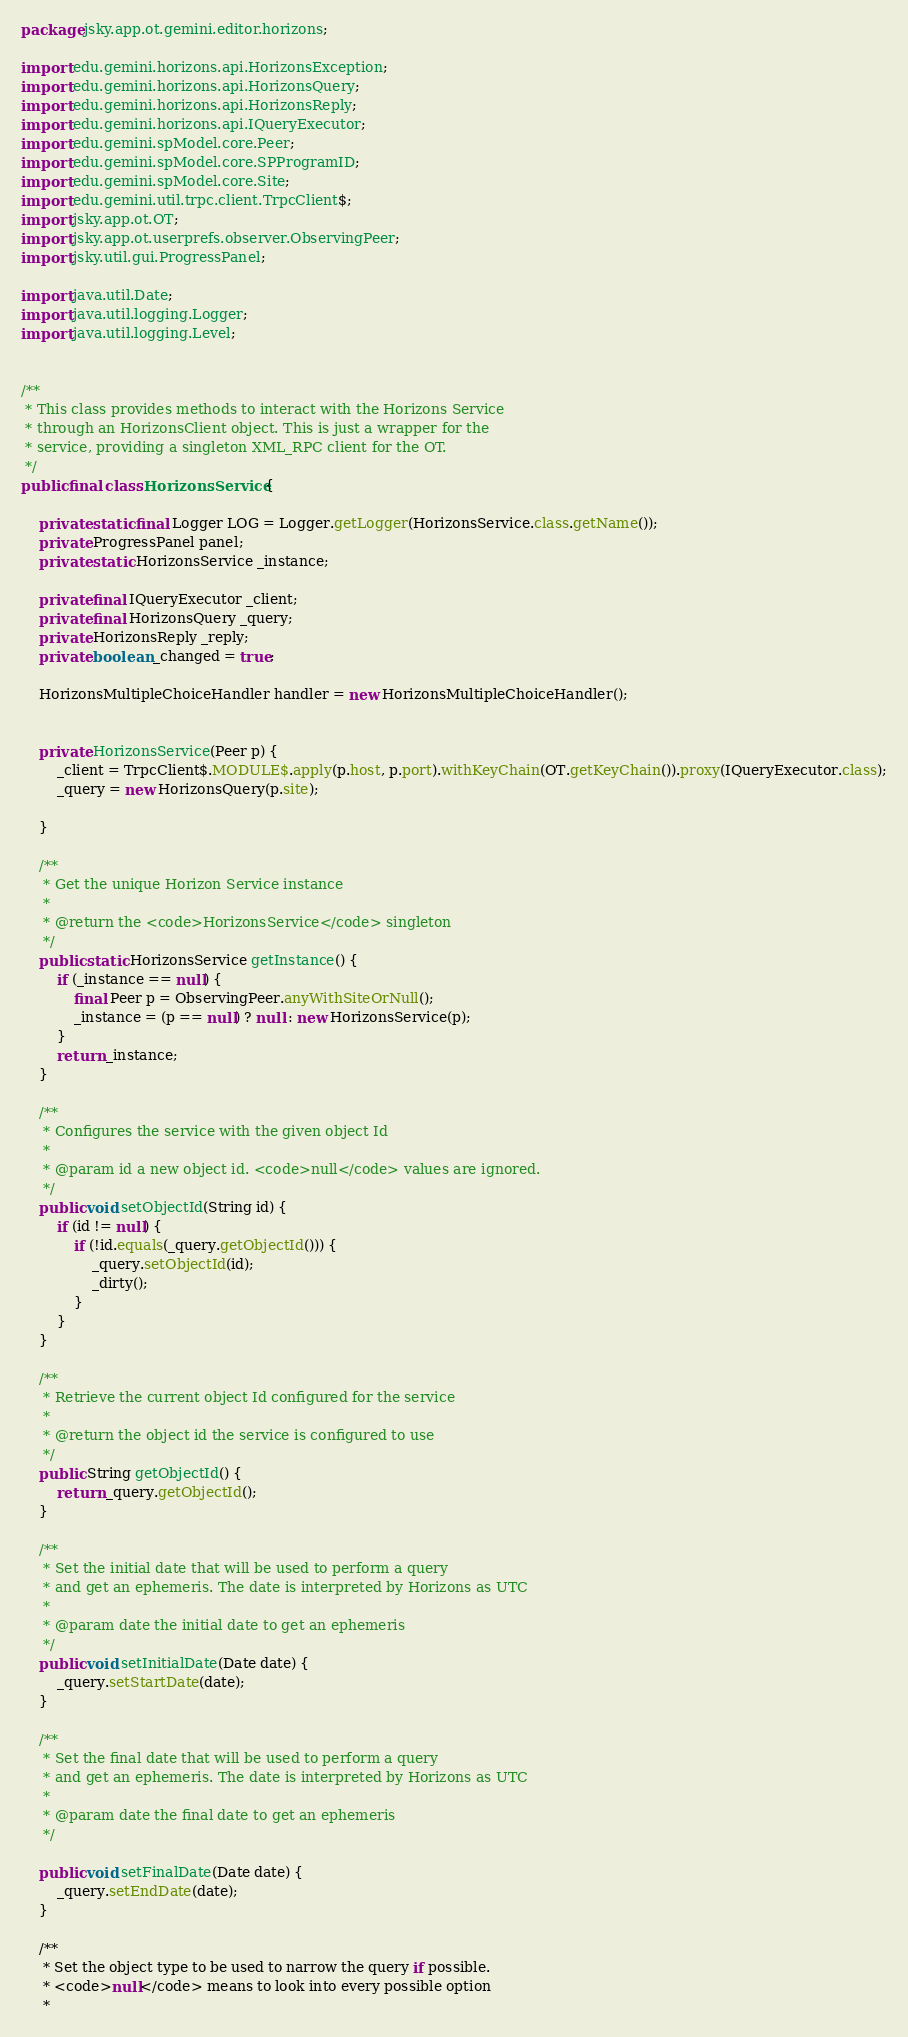<code> <loc_0><loc_0><loc_500><loc_500><_Java_>package jsky.app.ot.gemini.editor.horizons;

import edu.gemini.horizons.api.HorizonsException;
import edu.gemini.horizons.api.HorizonsQuery;
import edu.gemini.horizons.api.HorizonsReply;
import edu.gemini.horizons.api.IQueryExecutor;
import edu.gemini.spModel.core.Peer;
import edu.gemini.spModel.core.SPProgramID;
import edu.gemini.spModel.core.Site;
import edu.gemini.util.trpc.client.TrpcClient$;
import jsky.app.ot.OT;
import jsky.app.ot.userprefs.observer.ObservingPeer;
import jsky.util.gui.ProgressPanel;

import java.util.Date;
import java.util.logging.Logger;
import java.util.logging.Level;


/**
 * This class provides methods to interact with the Horizons Service
 * through an HorizonsClient object. This is just a wrapper for the
 * service, providing a singleton XML_RPC client for the OT.
 */
public final class HorizonsService {

    private static final Logger LOG = Logger.getLogger(HorizonsService.class.getName());
    private ProgressPanel panel;
    private static HorizonsService _instance;

    private final IQueryExecutor _client;
    private final HorizonsQuery _query;
    private HorizonsReply _reply;
    private boolean _changed = true;

    HorizonsMultipleChoiceHandler handler = new HorizonsMultipleChoiceHandler();


    private HorizonsService(Peer p) {
        _client = TrpcClient$.MODULE$.apply(p.host, p.port).withKeyChain(OT.getKeyChain()).proxy(IQueryExecutor.class);
        _query = new HorizonsQuery(p.site);

    }

    /**
     * Get the unique Horizon Service instance
     *
     * @return the <code>HorizonsService</code> singleton
     */
    public static HorizonsService getInstance() {
        if (_instance == null) {
            final Peer p = ObservingPeer.anyWithSiteOrNull();
            _instance = (p == null) ? null : new HorizonsService(p);
        }
        return _instance;
    }

    /**
     * Configures the service with the given object Id
     *
     * @param id a new object id. <code>null</code> values are ignored.
     */
    public void setObjectId(String id) {
        if (id != null) {
            if (!id.equals(_query.getObjectId())) {
                _query.setObjectId(id);
                _dirty();
            }
        }
    }

    /**
     * Retrieve the current object Id configured for the service
     *
     * @return the object id the service is configured to use
     */
    public String getObjectId() {
        return _query.getObjectId();
    }

    /**
     * Set the initial date that will be used to perform a query
     * and get an ephemeris. The date is interpreted by Horizons as UTC
     *
     * @param date the initial date to get an ephemeris
     */
    public void setInitialDate(Date date) {
        _query.setStartDate(date);
    }

    /**
     * Set the final date that will be used to perform a query
     * and get an ephemeris. The date is interpreted by Horizons as UTC
     *
     * @param date the final date to get an ephemeris
     */

    public void setFinalDate(Date date) {
        _query.setEndDate(date);
    }

    /**
     * Set the object type to be used to narrow the query if possible.
     * <code>null</code> means to look into every possible option
     *</code> 